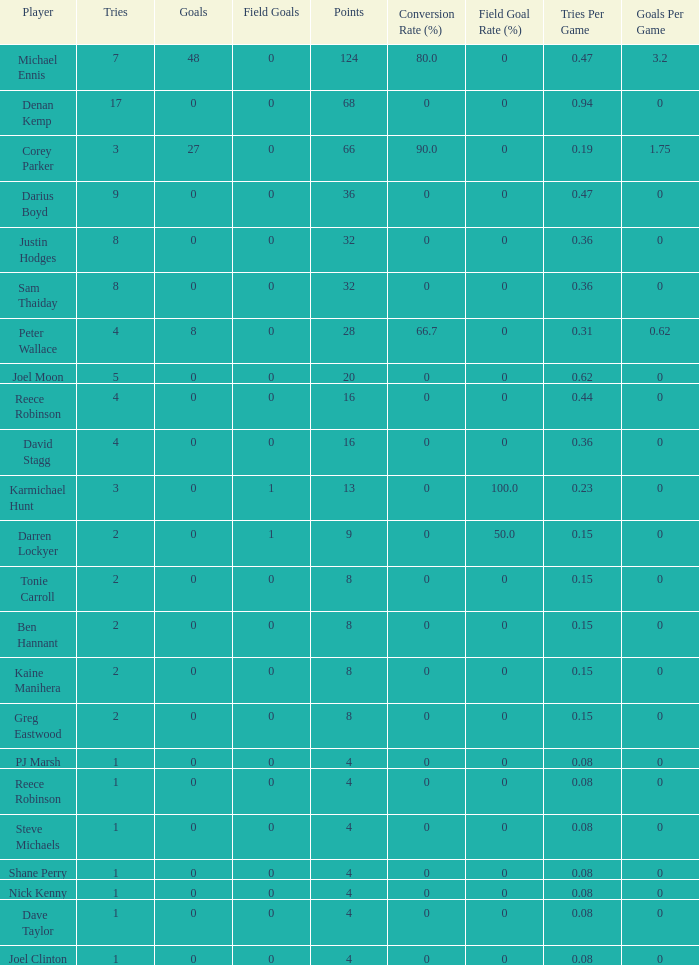What is the number of goals Dave Taylor, who has more than 1 tries, has? None. 